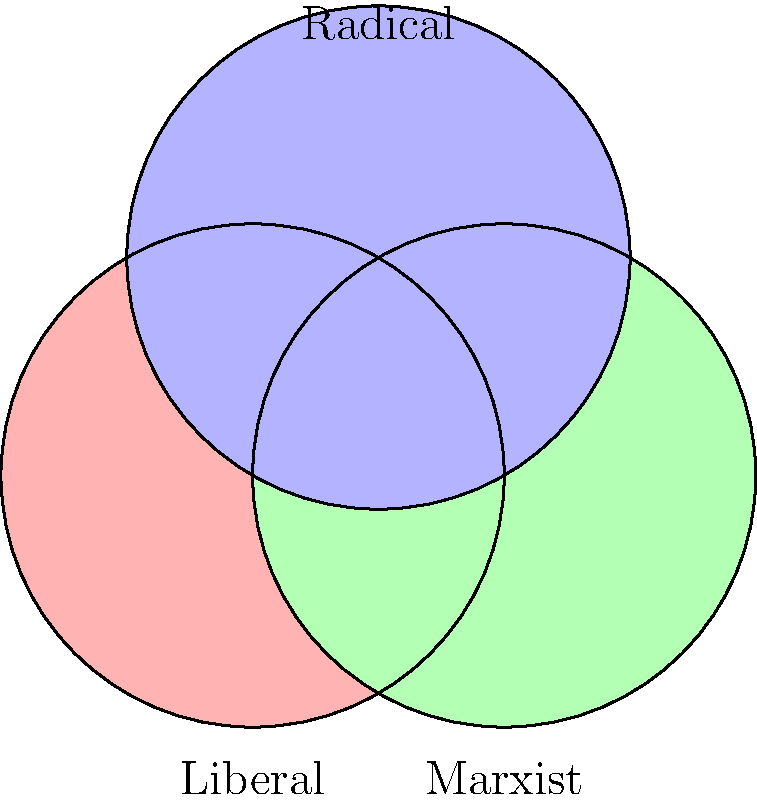Consider the space $X$ represented by the Venn diagram above, where each circle represents a different feminist ideology (Liberal, Marxist, and Radical). What is the fundamental group $\pi_1(X)$ of this space, and how does it reflect the intersectionality of these feminist perspectives? To determine the fundamental group of this space, we'll follow these steps:

1) First, observe that the space $X$ is homotopy equivalent to a bouquet of circles. The number of circles in this bouquet is equal to the number of holes in our space.

2) In this Venn diagram, we have:
   - 3 main circles (ideologies)
   - 3 pairwise intersections
   - 1 triple intersection

3) The number of holes is equal to the number of circles minus the number of intersections plus 1:
   $3 - 3 + 1 = 1$

4) Therefore, our space $X$ is homotopy equivalent to a single circle $S^1$.

5) The fundamental group of a circle is isomorphic to the integers under addition:
   $\pi_1(S^1) \cong \mathbb{Z}$

6) Thus, $\pi_1(X) \cong \mathbb{Z}$

This result reflects the intersectionality of feminist ideologies in the following way:

- The non-trivial fundamental group indicates that there are non-contractible loops in the space, representing the complexity and interconnectedness of these ideologies.
- The fact that it's $\mathbb{Z}$ suggests that while these ideologies have distinct characteristics, they are fundamentally connected in a single, coherent framework of feminist thought.
- The generator of $\mathbb{Z}$ can be seen as representing a path that traverses all three ideologies, embodying the intersectional approach that considers all perspectives simultaneously.
Answer: $\pi_1(X) \cong \mathbb{Z}$ 